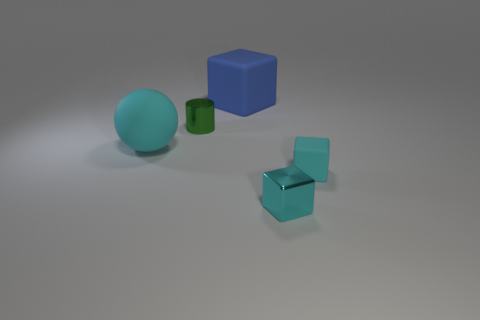Subtract all blue cubes. How many cubes are left? 2 Subtract all blocks. How many objects are left? 2 Subtract 1 cylinders. How many cylinders are left? 0 Add 5 cylinders. How many objects exist? 10 Subtract all blue cubes. How many cubes are left? 2 Subtract 0 red spheres. How many objects are left? 5 Subtract all red cubes. Subtract all purple cylinders. How many cubes are left? 3 Subtract all green balls. How many gray cubes are left? 0 Subtract all large blue things. Subtract all large yellow rubber spheres. How many objects are left? 4 Add 2 metallic things. How many metallic things are left? 4 